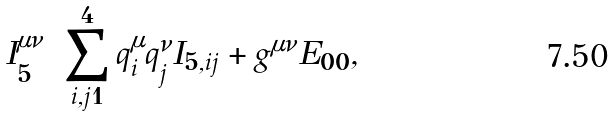<formula> <loc_0><loc_0><loc_500><loc_500>I _ { 5 } ^ { \mu \nu } = \sum _ { i , j = 1 } ^ { 4 } q _ { i } ^ { \mu } q _ { j } ^ { \nu } I _ { 5 , i j } + g ^ { \mu \nu } E _ { 0 0 } ,</formula> 